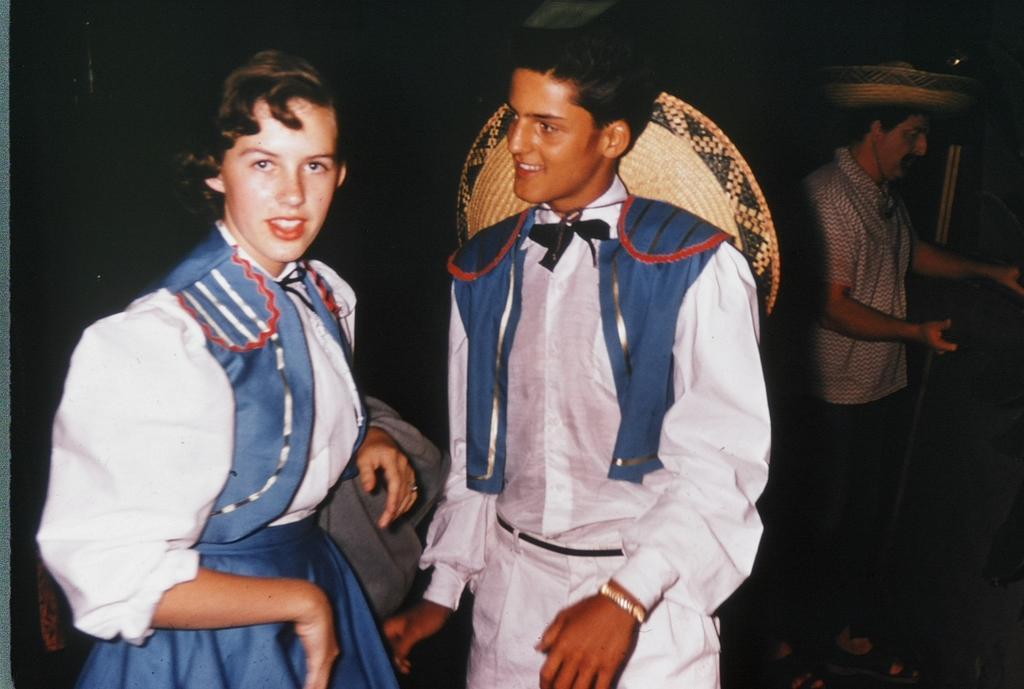Can you describe this image briefly? In this picture we can see three people, hats, some objects and two people are smiling and in the background it is dark. 